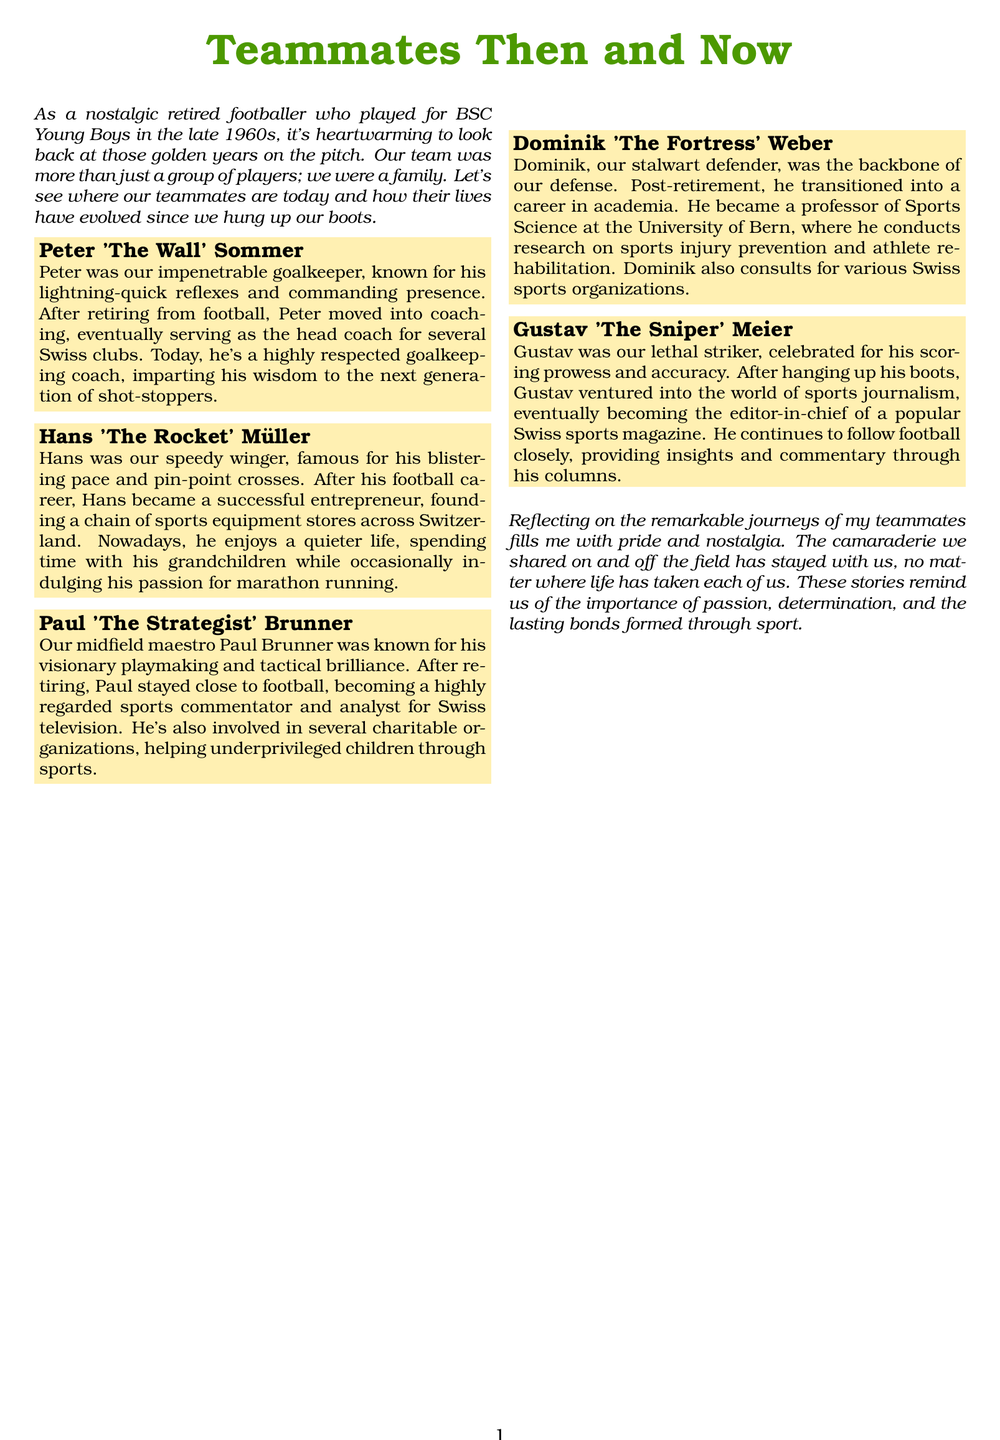What position did Peter Sommer play? Peter Sommer was the goalkeeper for BSC Young Boys during the late 1960s.
Answer: goalkeeper What was Hans Müller's nickname? Hans was known as "The Rocket" due to his speedy playing style.
Answer: The Rocket What career did Dominik Weber pursue after football? After retiring, Dominik Weber became a professor of Sports Science.
Answer: professor Which Swiss city is Paul Brunner associated with as a commentator? Paul Brunner is involved in sports commentary for Swiss television after his playing career.
Answer: Swiss television What type of business did Hans Müller start? After his football career, Hans Müller founded a chain of sports equipment stores.
Answer: sports equipment stores Who is the editor-in-chief of a Swiss sports magazine? Gustav Meier became the editor-in-chief after his football career.
Answer: Gustav Meier What did Peter Sommer do after retiring from football? Peter Sommer moved into coaching after his playing career.
Answer: coaching What is the main theme of the document? The document reflects on the careers of former teammates from BSC Young Boys.
Answer: teammates' careers How did Paul Brunner contribute to society after his retirement? Paul Brunner is involved in several charitable organizations helping underprivileged children.
Answer: charitable organizations 